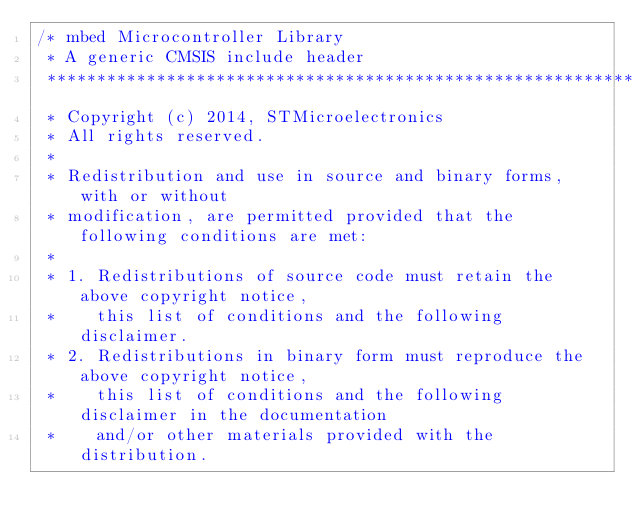<code> <loc_0><loc_0><loc_500><loc_500><_C_>/* mbed Microcontroller Library
 * A generic CMSIS include header
 *******************************************************************************
 * Copyright (c) 2014, STMicroelectronics
 * All rights reserved.
 *
 * Redistribution and use in source and binary forms, with or without
 * modification, are permitted provided that the following conditions are met:
 *
 * 1. Redistributions of source code must retain the above copyright notice,
 *    this list of conditions and the following disclaimer.
 * 2. Redistributions in binary form must reproduce the above copyright notice,
 *    this list of conditions and the following disclaimer in the documentation
 *    and/or other materials provided with the distribution.</code> 